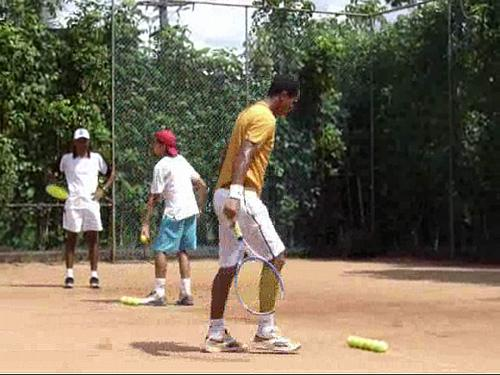What is the man looking down at?

Choices:
A) onions
B) cue balls
C) tennis balls
D) apples tennis balls 